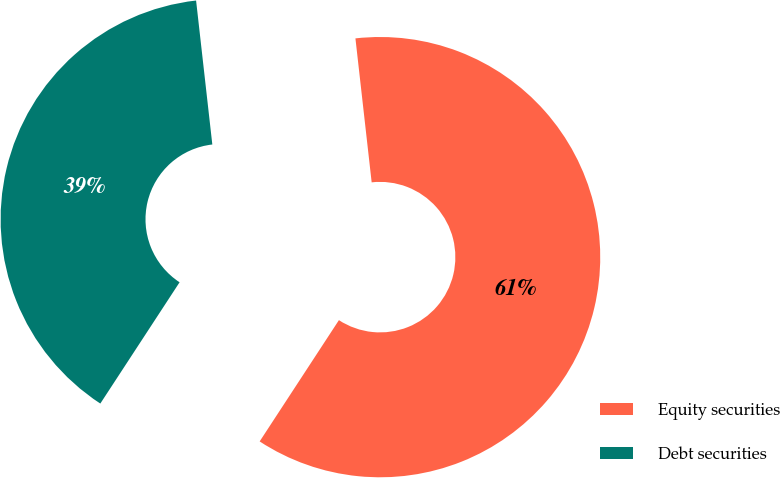Convert chart. <chart><loc_0><loc_0><loc_500><loc_500><pie_chart><fcel>Equity securities<fcel>Debt securities<nl><fcel>61.0%<fcel>39.0%<nl></chart> 